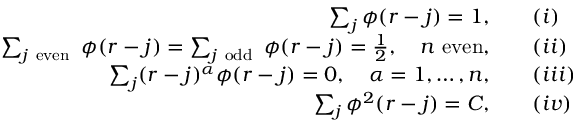Convert formula to latex. <formula><loc_0><loc_0><loc_500><loc_500>\begin{array} { r l } { \sum _ { j } \phi ( r - j ) = 1 , } & { \quad ( \romannumeral 1 ) } \\ { \sum _ { j e v e n } \phi ( r - j ) = \sum _ { j o d d } \phi ( r - j ) = \frac { 1 } { 2 } , \quad n e v e n , } & { \quad ( \romannumeral 2 ) } \\ { \sum _ { j } ( r - j ) ^ { \alpha } \phi ( r - j ) = 0 , \quad \alpha = 1 , \dots , n , } & { \quad ( \romannumeral 3 ) } \\ { \sum _ { j } \phi ^ { 2 } ( r - j ) = C , } & { \quad ( \romannumeral 4 ) } \end{array}</formula> 